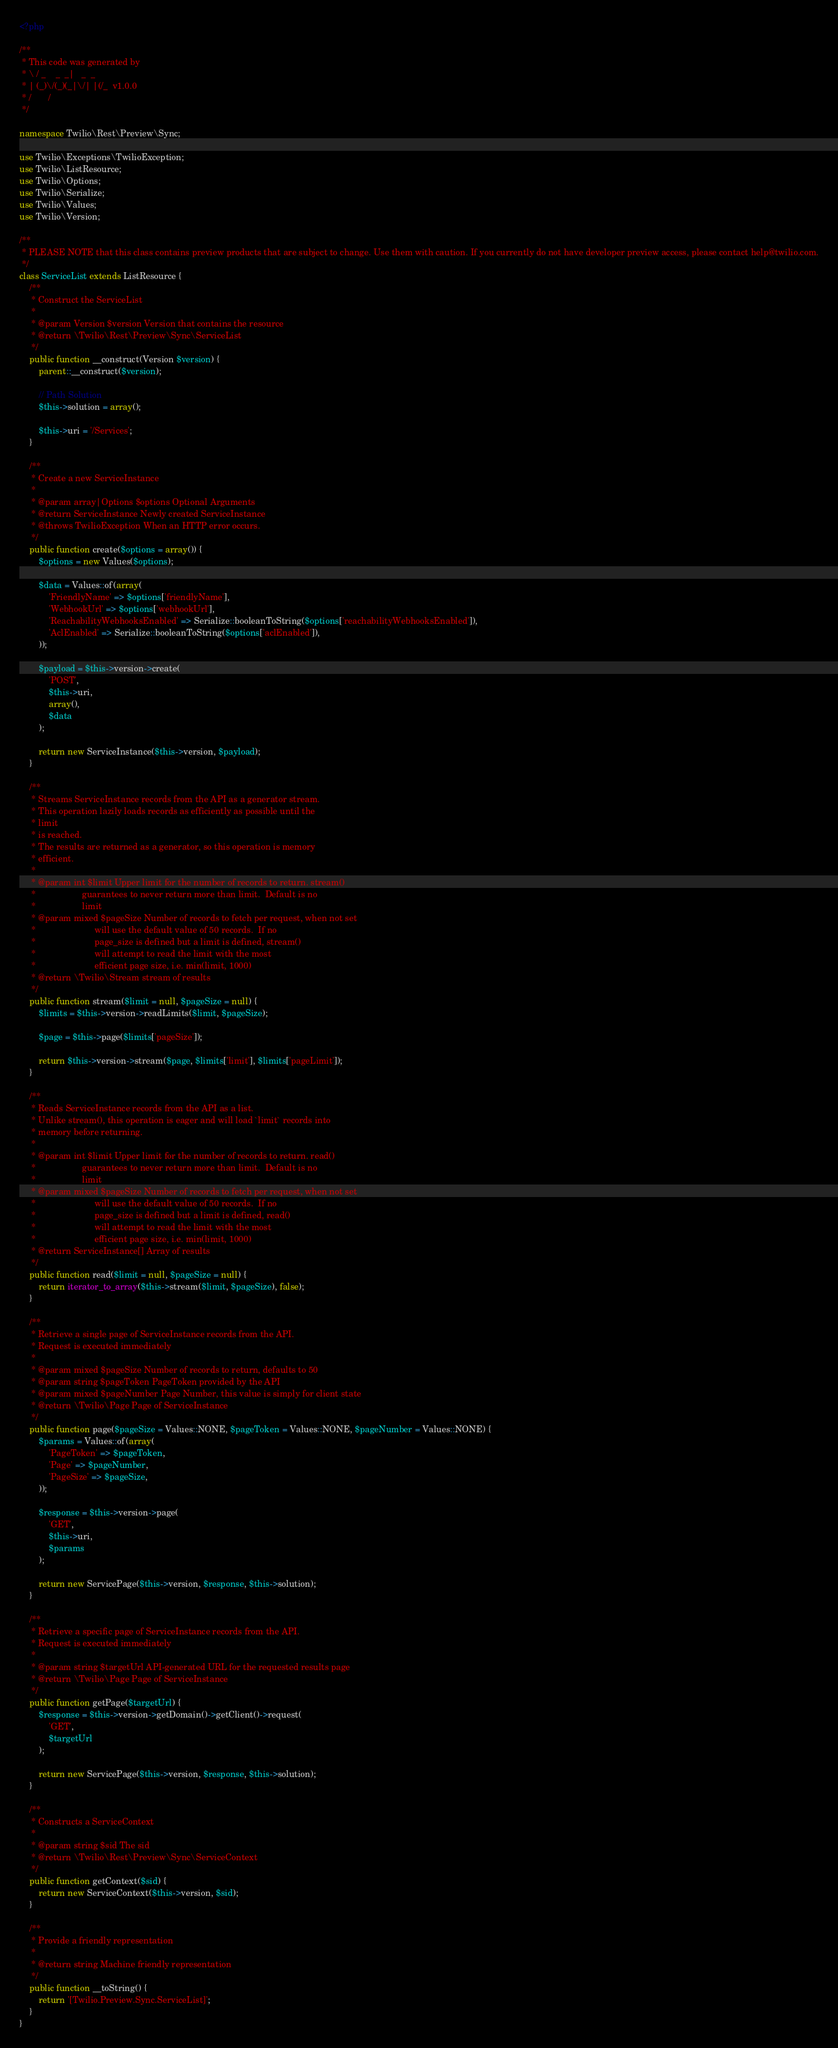Convert code to text. <code><loc_0><loc_0><loc_500><loc_500><_PHP_><?php

/**
 * This code was generated by
 * \ / _    _  _|   _  _
 * | (_)\/(_)(_|\/| |(/_  v1.0.0
 * /       /
 */

namespace Twilio\Rest\Preview\Sync;

use Twilio\Exceptions\TwilioException;
use Twilio\ListResource;
use Twilio\Options;
use Twilio\Serialize;
use Twilio\Values;
use Twilio\Version;

/**
 * PLEASE NOTE that this class contains preview products that are subject to change. Use them with caution. If you currently do not have developer preview access, please contact help@twilio.com.
 */
class ServiceList extends ListResource {
    /**
     * Construct the ServiceList
     *
     * @param Version $version Version that contains the resource
     * @return \Twilio\Rest\Preview\Sync\ServiceList
     */
    public function __construct(Version $version) {
        parent::__construct($version);

        // Path Solution
        $this->solution = array();

        $this->uri = '/Services';
    }

    /**
     * Create a new ServiceInstance
     *
     * @param array|Options $options Optional Arguments
     * @return ServiceInstance Newly created ServiceInstance
     * @throws TwilioException When an HTTP error occurs.
     */
    public function create($options = array()) {
        $options = new Values($options);

        $data = Values::of(array(
            'FriendlyName' => $options['friendlyName'],
            'WebhookUrl' => $options['webhookUrl'],
            'ReachabilityWebhooksEnabled' => Serialize::booleanToString($options['reachabilityWebhooksEnabled']),
            'AclEnabled' => Serialize::booleanToString($options['aclEnabled']),
        ));

        $payload = $this->version->create(
            'POST',
            $this->uri,
            array(),
            $data
        );

        return new ServiceInstance($this->version, $payload);
    }

    /**
     * Streams ServiceInstance records from the API as a generator stream.
     * This operation lazily loads records as efficiently as possible until the
     * limit
     * is reached.
     * The results are returned as a generator, so this operation is memory
     * efficient.
     *
     * @param int $limit Upper limit for the number of records to return. stream()
     *                   guarantees to never return more than limit.  Default is no
     *                   limit
     * @param mixed $pageSize Number of records to fetch per request, when not set
     *                        will use the default value of 50 records.  If no
     *                        page_size is defined but a limit is defined, stream()
     *                        will attempt to read the limit with the most
     *                        efficient page size, i.e. min(limit, 1000)
     * @return \Twilio\Stream stream of results
     */
    public function stream($limit = null, $pageSize = null) {
        $limits = $this->version->readLimits($limit, $pageSize);

        $page = $this->page($limits['pageSize']);

        return $this->version->stream($page, $limits['limit'], $limits['pageLimit']);
    }

    /**
     * Reads ServiceInstance records from the API as a list.
     * Unlike stream(), this operation is eager and will load `limit` records into
     * memory before returning.
     *
     * @param int $limit Upper limit for the number of records to return. read()
     *                   guarantees to never return more than limit.  Default is no
     *                   limit
     * @param mixed $pageSize Number of records to fetch per request, when not set
     *                        will use the default value of 50 records.  If no
     *                        page_size is defined but a limit is defined, read()
     *                        will attempt to read the limit with the most
     *                        efficient page size, i.e. min(limit, 1000)
     * @return ServiceInstance[] Array of results
     */
    public function read($limit = null, $pageSize = null) {
        return iterator_to_array($this->stream($limit, $pageSize), false);
    }

    /**
     * Retrieve a single page of ServiceInstance records from the API.
     * Request is executed immediately
     *
     * @param mixed $pageSize Number of records to return, defaults to 50
     * @param string $pageToken PageToken provided by the API
     * @param mixed $pageNumber Page Number, this value is simply for client state
     * @return \Twilio\Page Page of ServiceInstance
     */
    public function page($pageSize = Values::NONE, $pageToken = Values::NONE, $pageNumber = Values::NONE) {
        $params = Values::of(array(
            'PageToken' => $pageToken,
            'Page' => $pageNumber,
            'PageSize' => $pageSize,
        ));

        $response = $this->version->page(
            'GET',
            $this->uri,
            $params
        );

        return new ServicePage($this->version, $response, $this->solution);
    }

    /**
     * Retrieve a specific page of ServiceInstance records from the API.
     * Request is executed immediately
     *
     * @param string $targetUrl API-generated URL for the requested results page
     * @return \Twilio\Page Page of ServiceInstance
     */
    public function getPage($targetUrl) {
        $response = $this->version->getDomain()->getClient()->request(
            'GET',
            $targetUrl
        );

        return new ServicePage($this->version, $response, $this->solution);
    }

    /**
     * Constructs a ServiceContext
     *
     * @param string $sid The sid
     * @return \Twilio\Rest\Preview\Sync\ServiceContext
     */
    public function getContext($sid) {
        return new ServiceContext($this->version, $sid);
    }

    /**
     * Provide a friendly representation
     *
     * @return string Machine friendly representation
     */
    public function __toString() {
        return '[Twilio.Preview.Sync.ServiceList]';
    }
}</code> 